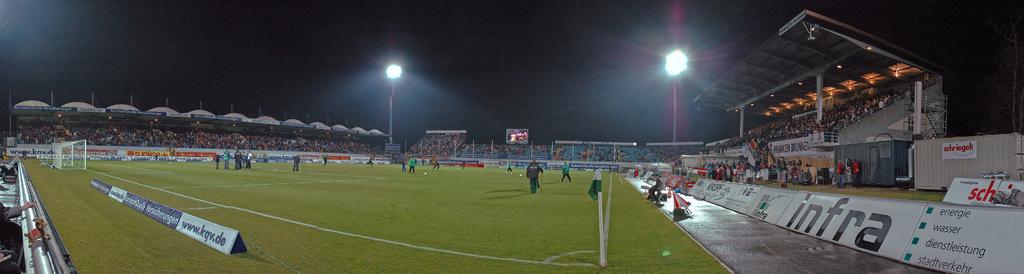Which website is featured on the small white banner?
Give a very brief answer. Infra. Tho sponsors this field?
Provide a short and direct response. Infra. 